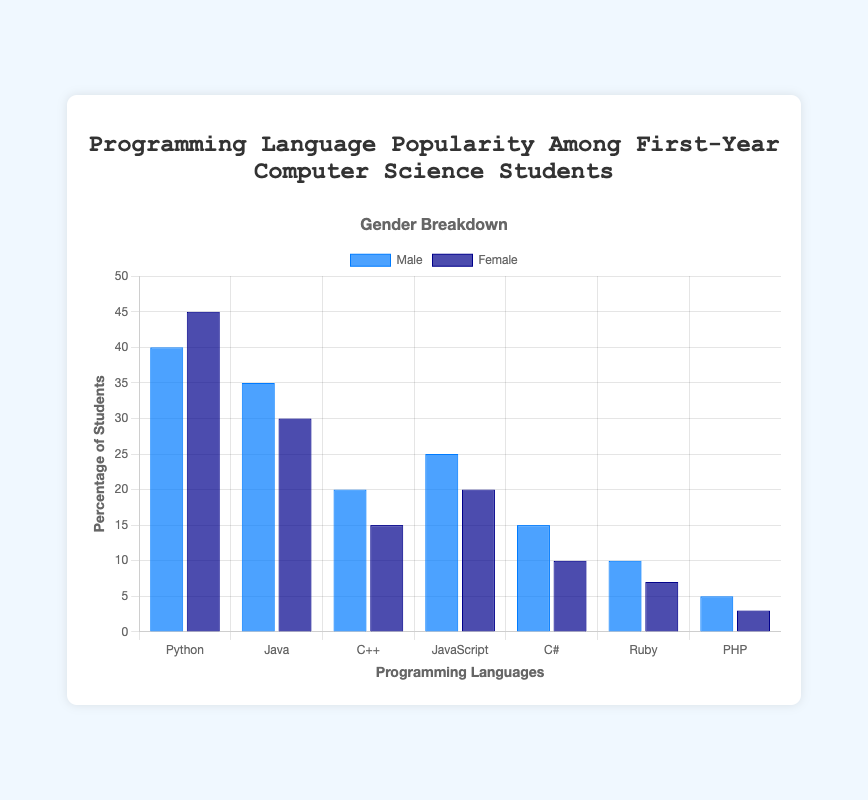Which programming language is the most popular among both male and female students? By visually inspecting the bar chart, we observe that the tallest bars (both blue and dark blue) correspond to Python for both male and female students. Therefore, Python is the most popular programming language among both genders.
Answer: Python Which gender has a higher preference for JavaScript, and by how much? For JavaScript, the blue bar (representing males) and the dark blue bar (representing females) have heights of 25 and 20 respectively. The difference is calculated as 25 - 20 = 5.
Answer: Male, by 5 What is the average popularity of C++ among both male and female students? The popularity of C++ is 20 for male students and 15 for female students. The average is calculated by (20 + 15) / 2 = 17.5.
Answer: 17.5 Which language has the smallest difference in popularity between male and female students? By comparing the differences: Python (5), Java (5), C++ (5), JavaScript (5), C# (5), Ruby (3), PHP (2), we see that PHP has the smallest difference.
Answer: PHP How many more female students prefer Python compared to those who prefer C++? For Python, 45 female students prefer it, and for C++, 15 female students prefer it. The difference is 45 - 15 = 30.
Answer: 30 Between Python and Java, which one has a higher combined popularity (male + female) and by how much? Python's combined popularity is 40 + 45 = 85, and Java's is 35 + 30 = 65. The difference is 85 - 65 = 20.
Answer: Python, by 20 Which gender shows a higher preference for the least popular language and what is that language? PHP is the least popular language, with popularity of 5 among male students and 3 among female students. Therefore, male students show a higher preference.
Answer: Male, PHP Summing the number of male students who prefer Python and JavaScript, and then comparing to the number of female students who prefer C++ and PHP, which group is larger? Sum for male students: Python (40) + JavaScript (25) = 65. Sum for female students: C++ (15) + PHP (3) = 18. The male group is larger.
Answer: Male, Python/JavaScript Which language has the highest disparity in popularity between genders? By calculating the differences: Python (5), Java (5), C++ (5), JavaScript (5), C# (5), Ruby (3), PHP (2), we see Python, Java, C++, JavaScript, and C# all have the same highest disparity of 5.
Answer: Python, Java, C++, JavaScript, C# What percentage of students prefer JavaScript overall? From both genders, the total number of students who prefer JavaScript is 25 (male) + 20 (female) = 45. Out of the total 175 (sum of all preferences), the percentage is (45/175) * 100 = 25.71.
Answer: 25.71 